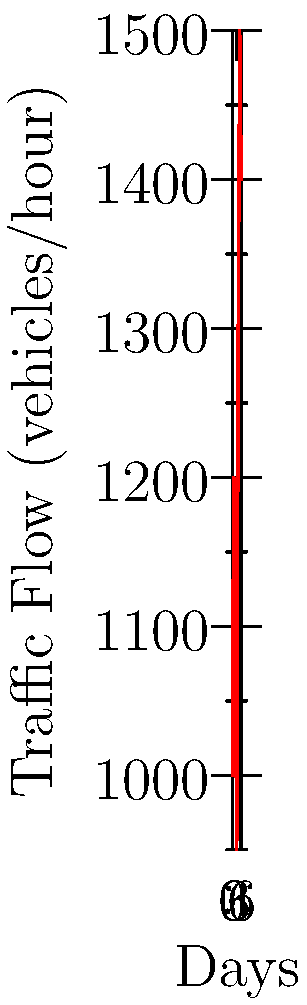Analyze the line graph showing traffic flow patterns over a week. What is the percentage increase in traffic flow from Thursday to Friday? To calculate the percentage increase in traffic flow from Thursday to Friday, we need to follow these steps:

1. Identify the traffic flow values:
   Thursday (Day 3): 950 vehicles/hour
   Friday (Day 4): 1300 vehicles/hour

2. Calculate the difference in traffic flow:
   Difference = Friday value - Thursday value
   Difference = 1300 - 950 = 350 vehicles/hour

3. Calculate the percentage increase:
   Percentage increase = (Increase / Original value) × 100
   Percentage increase = (350 / 950) × 100

4. Solve the equation:
   Percentage increase = 0.3684 × 100 = 36.84%

Therefore, the percentage increase in traffic flow from Thursday to Friday is approximately 36.84%.
Answer: 36.84% 